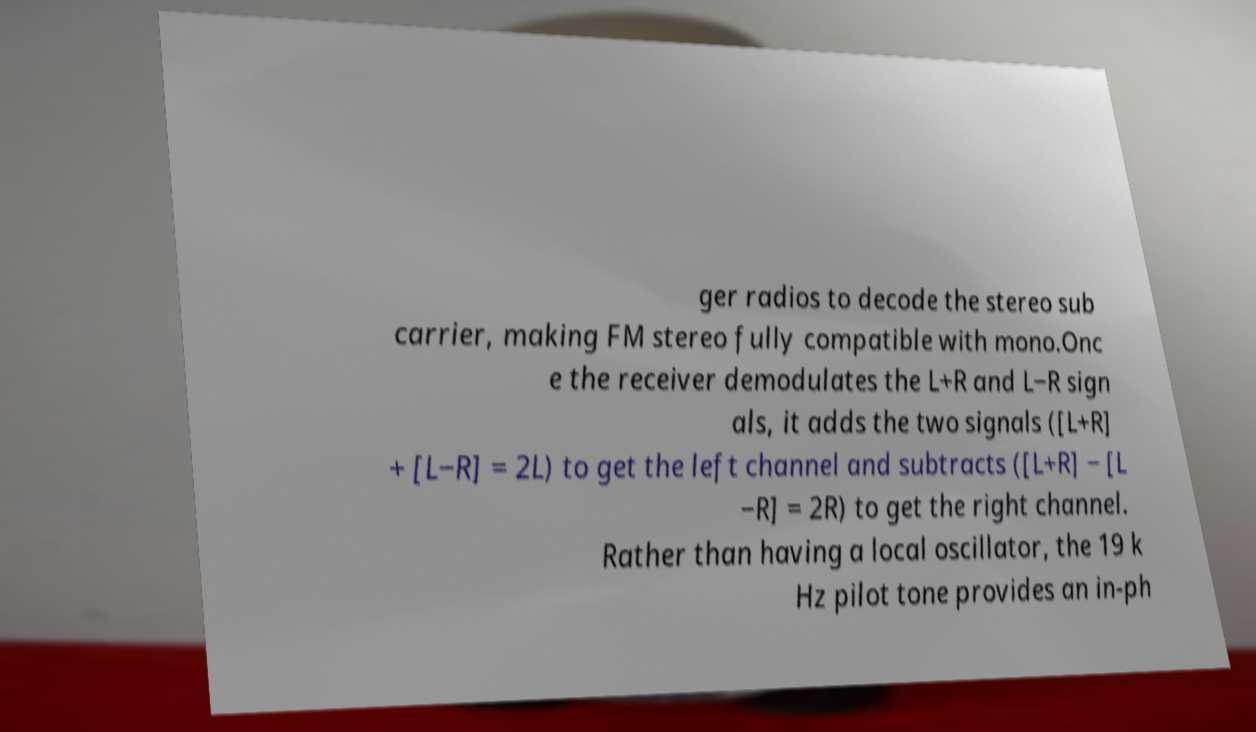Can you read and provide the text displayed in the image?This photo seems to have some interesting text. Can you extract and type it out for me? ger radios to decode the stereo sub carrier, making FM stereo fully compatible with mono.Onc e the receiver demodulates the L+R and L−R sign als, it adds the two signals ([L+R] + [L−R] = 2L) to get the left channel and subtracts ([L+R] − [L −R] = 2R) to get the right channel. Rather than having a local oscillator, the 19 k Hz pilot tone provides an in-ph 